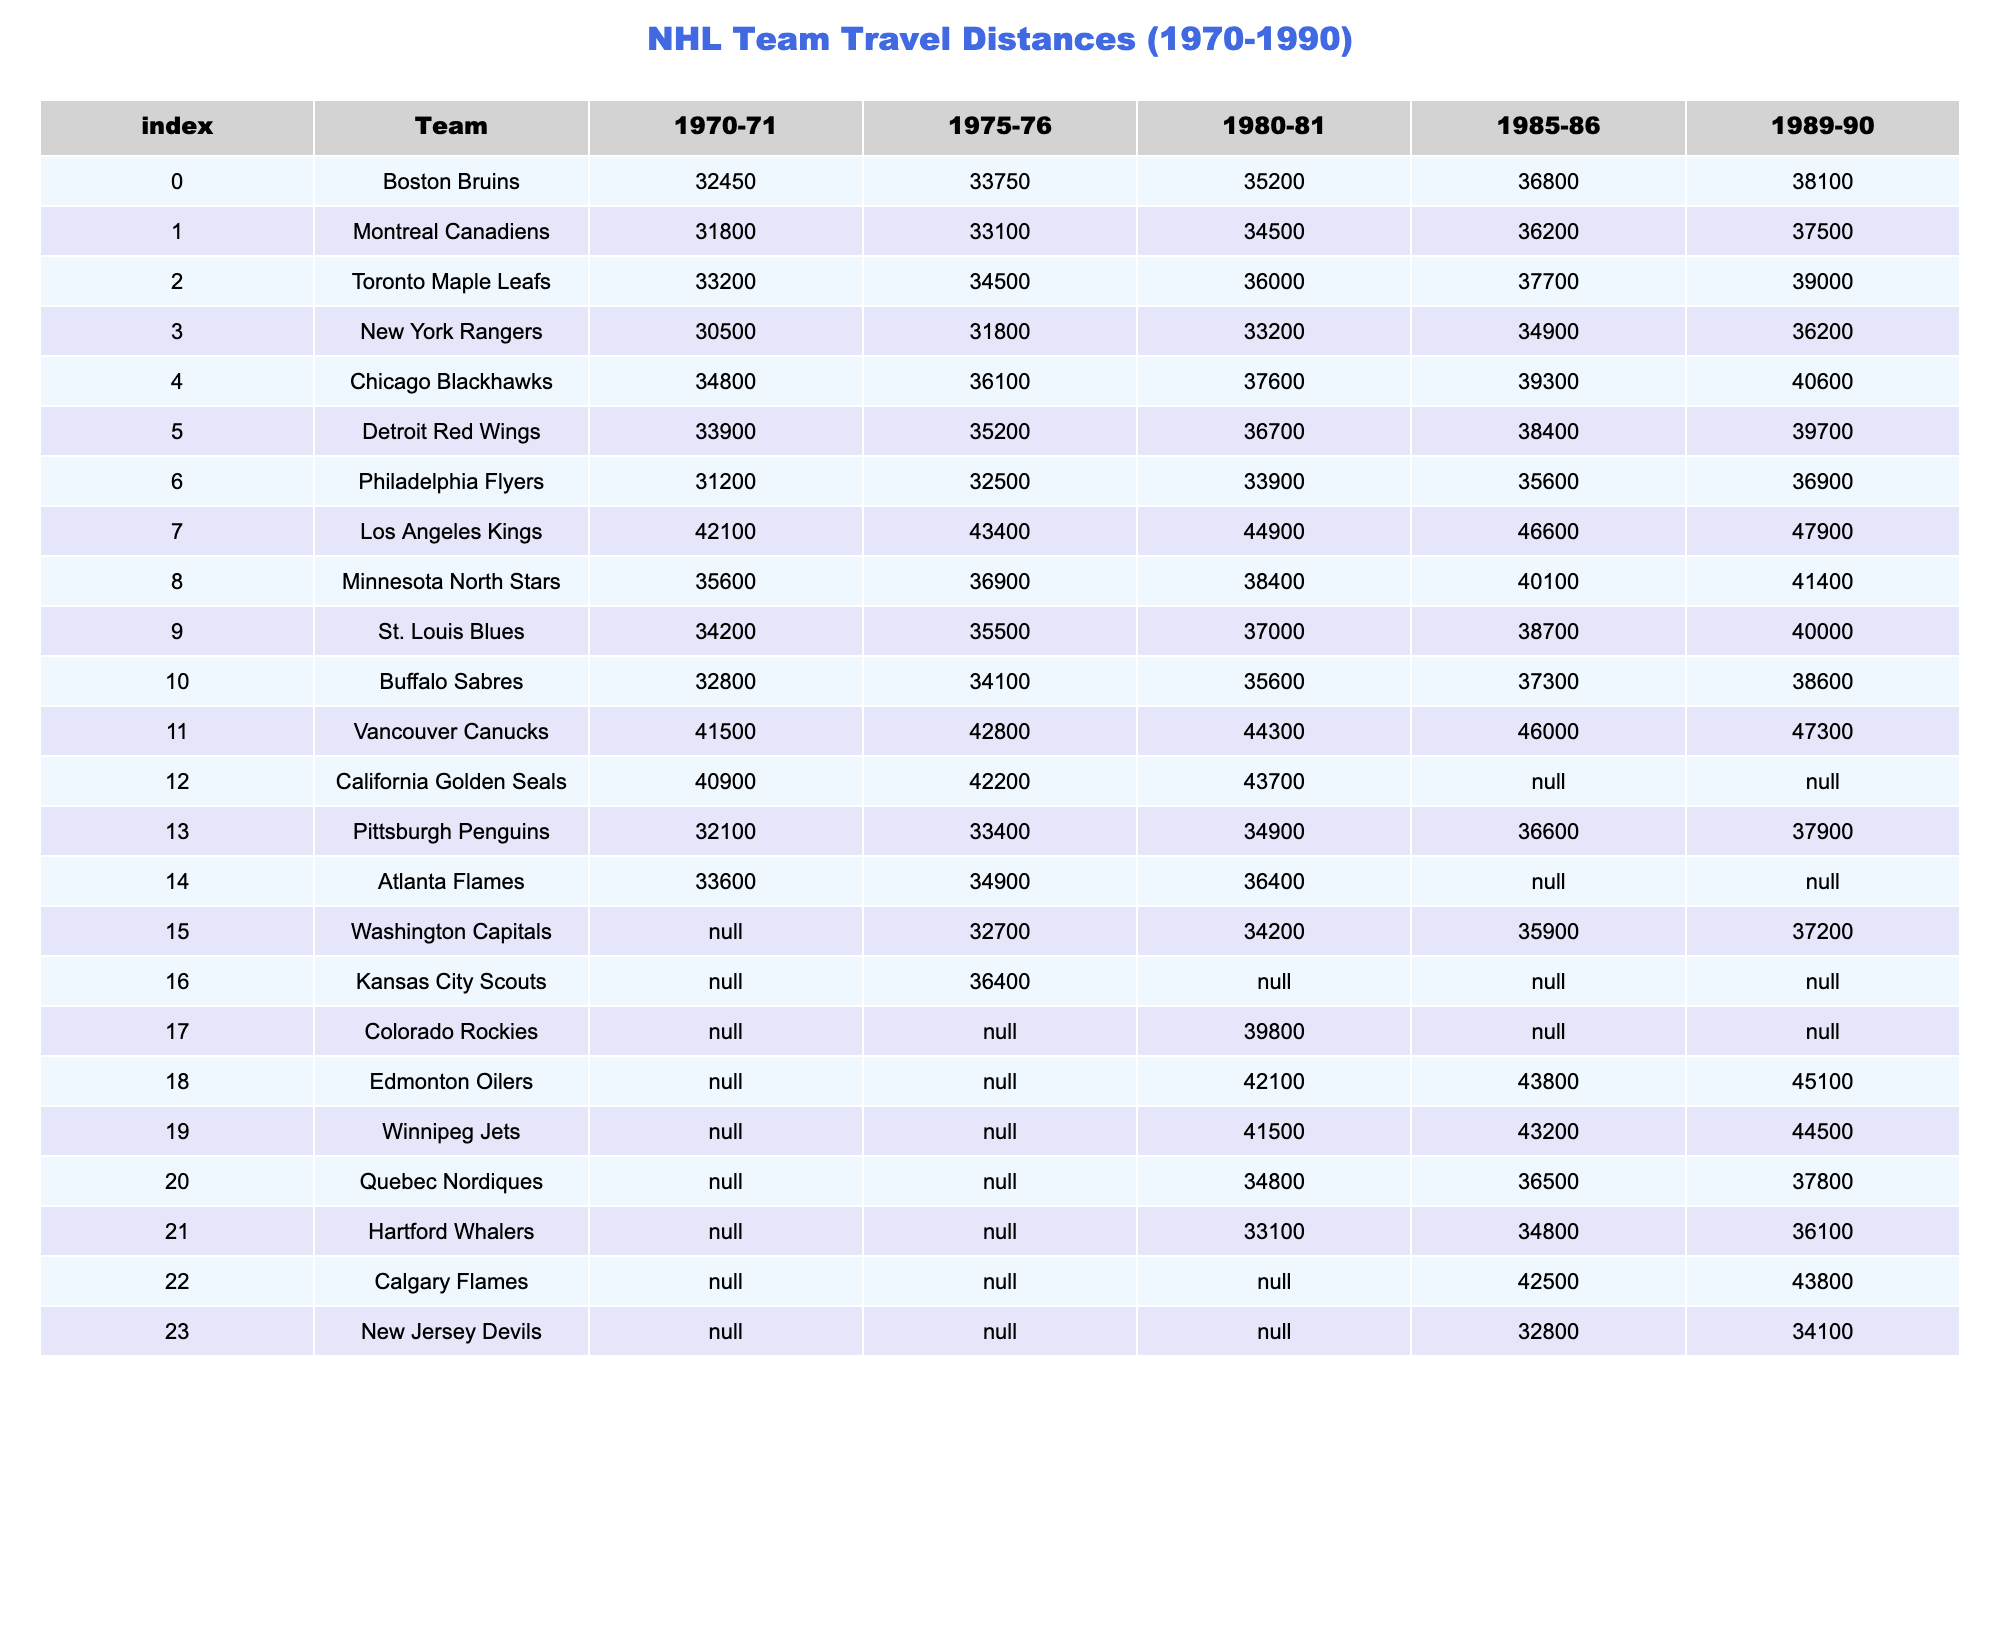What was the total travel distance for the Montreal Canadiens in 1989-90? The travel distance for the Montreal Canadiens in 1989-90 is listed in the table, which shows a value of 37500.
Answer: 37500 Which team had the longest travel distance in the 1975-76 season? By looking at the table for the 1975-76 season, the Los Angeles Kings have the highest distance of 43400.
Answer: Los Angeles Kings What was the average travel distance for the Boston Bruins from 1970-71 to 1989-90? To find the average, we add the travel distances for the Boston Bruins from each year: 32450 + 33750 + 35200 + 36800 + 38100 = 176300. Then, divide by 5 (the number of seasons): 176300 / 5 = 35260.
Answer: 35260 Did any team have a travel distance recorded for every year from 1970 to 1990? Upon inspection of the table, the California Golden Seals show 'N/A' for the 1985-86 and 1989-90 seasons indicating missing data; hence no team has complete data for all years.
Answer: No Which team has the smallest travel distance in the 1985-86 season, and what is that distance? Looking at the 1985-86 data in the table, the team with the smallest travel distance is the Philadelphia Flyers with a distance of 35600.
Answer: Philadelphia Flyers, 35600 What is the difference in travel distance between the New York Rangers in 1985-86 and the Toronto Maple Leafs in 1989-90? The travel distance for New York Rangers in 1985-86 is 34900, and for Toronto Maple Leafs in 1989-90 it is 39000. The difference is 39000 - 34900 = 4100.
Answer: 4100 Which team had consistently increasing travel distances from 1970-71 to 1989-90? By evaluating the table, the Chicago Blackhawks show a consistent increase each year: 34800, 36100, 37600, 39300, and 40600.
Answer: Chicago Blackhawks What was the travel distance for the Winnipeg Jets in 1985-86? According to the table, the travel distance for the Winnipeg Jets in the 1985-86 season is indicated as 43200.
Answer: 43200 Which two teams had the highest travel distance in the 1989-90 season? In the 1989-90 season, comparing the distances, the teams with the highest distances are the Los Angeles Kings at 47900 and the Vancouver Canucks at 47300.
Answer: Los Angeles Kings and Vancouver Canucks What is the median travel distance for the teams listed in 1970-71? To find the median, we list the travel distances for each team in 1970-71: 30500, 31800, 32450, 32800, 33200, 33900, 34800, 35600, 42100. The median of this ordered list is the average of 33900 and 34800: (33900 + 34800) / 2 = 34350.
Answer: 34350 